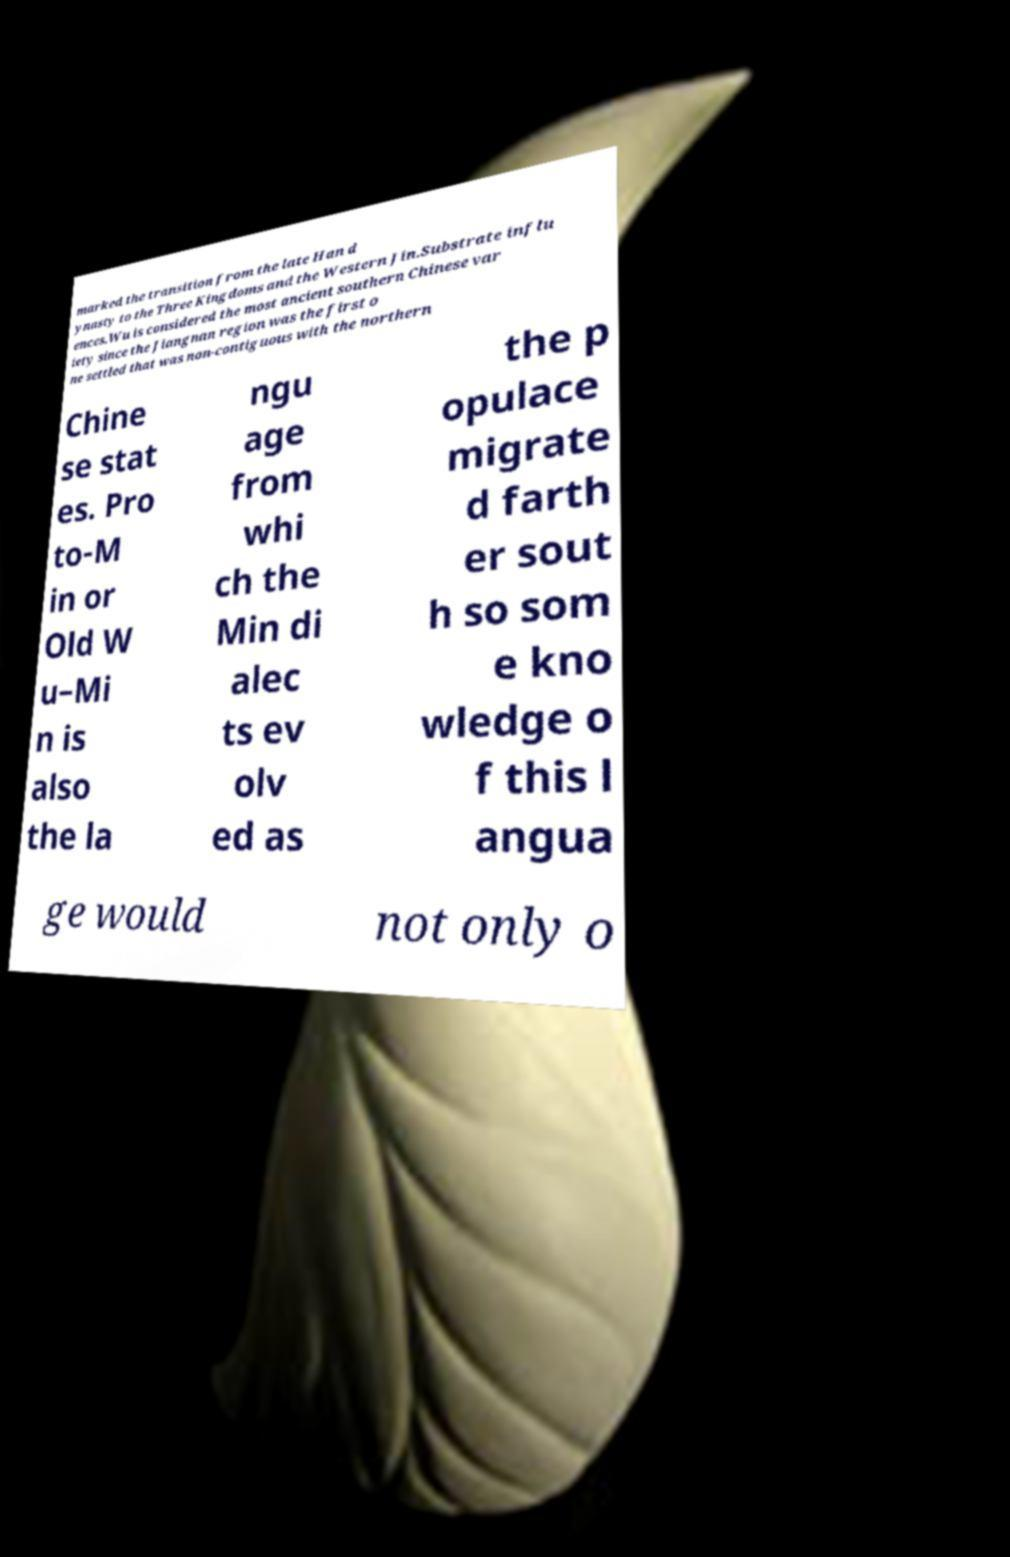Could you extract and type out the text from this image? marked the transition from the late Han d ynasty to the Three Kingdoms and the Western Jin.Substrate influ ences.Wu is considered the most ancient southern Chinese var iety since the Jiangnan region was the first o ne settled that was non-contiguous with the northern Chine se stat es. Pro to-M in or Old W u–Mi n is also the la ngu age from whi ch the Min di alec ts ev olv ed as the p opulace migrate d farth er sout h so som e kno wledge o f this l angua ge would not only o 